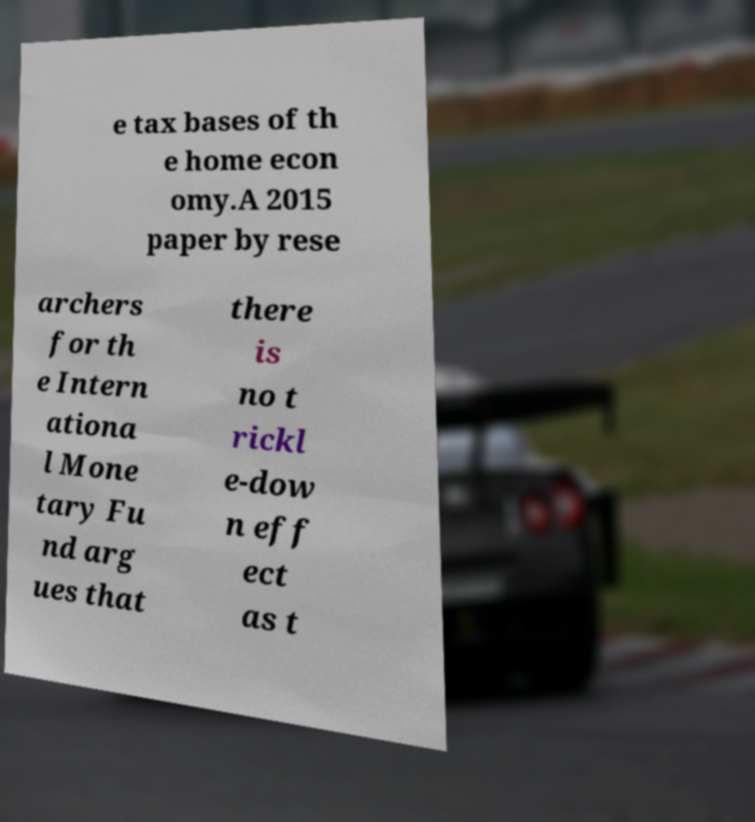I need the written content from this picture converted into text. Can you do that? e tax bases of th e home econ omy.A 2015 paper by rese archers for th e Intern ationa l Mone tary Fu nd arg ues that there is no t rickl e-dow n eff ect as t 